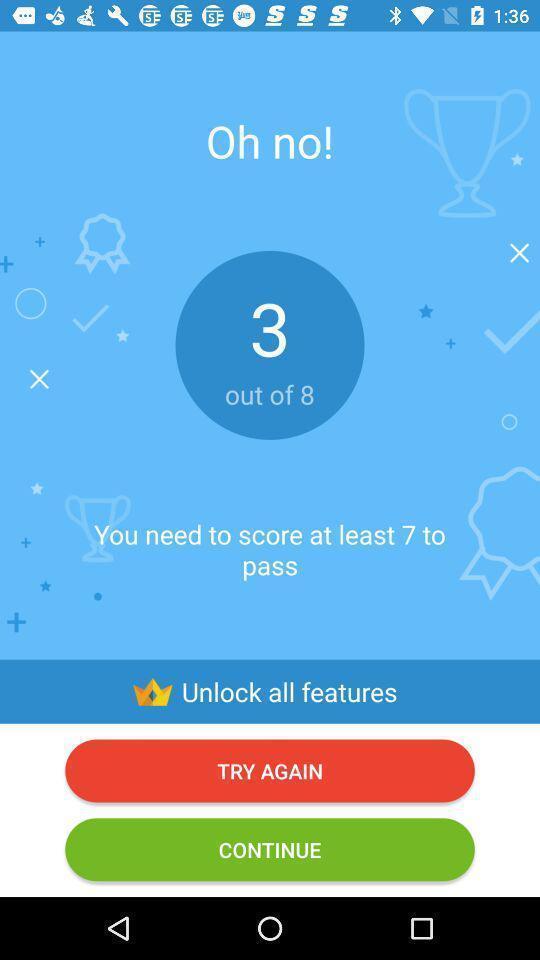Please provide a description for this image. Screen shows to pass a fun game test. 